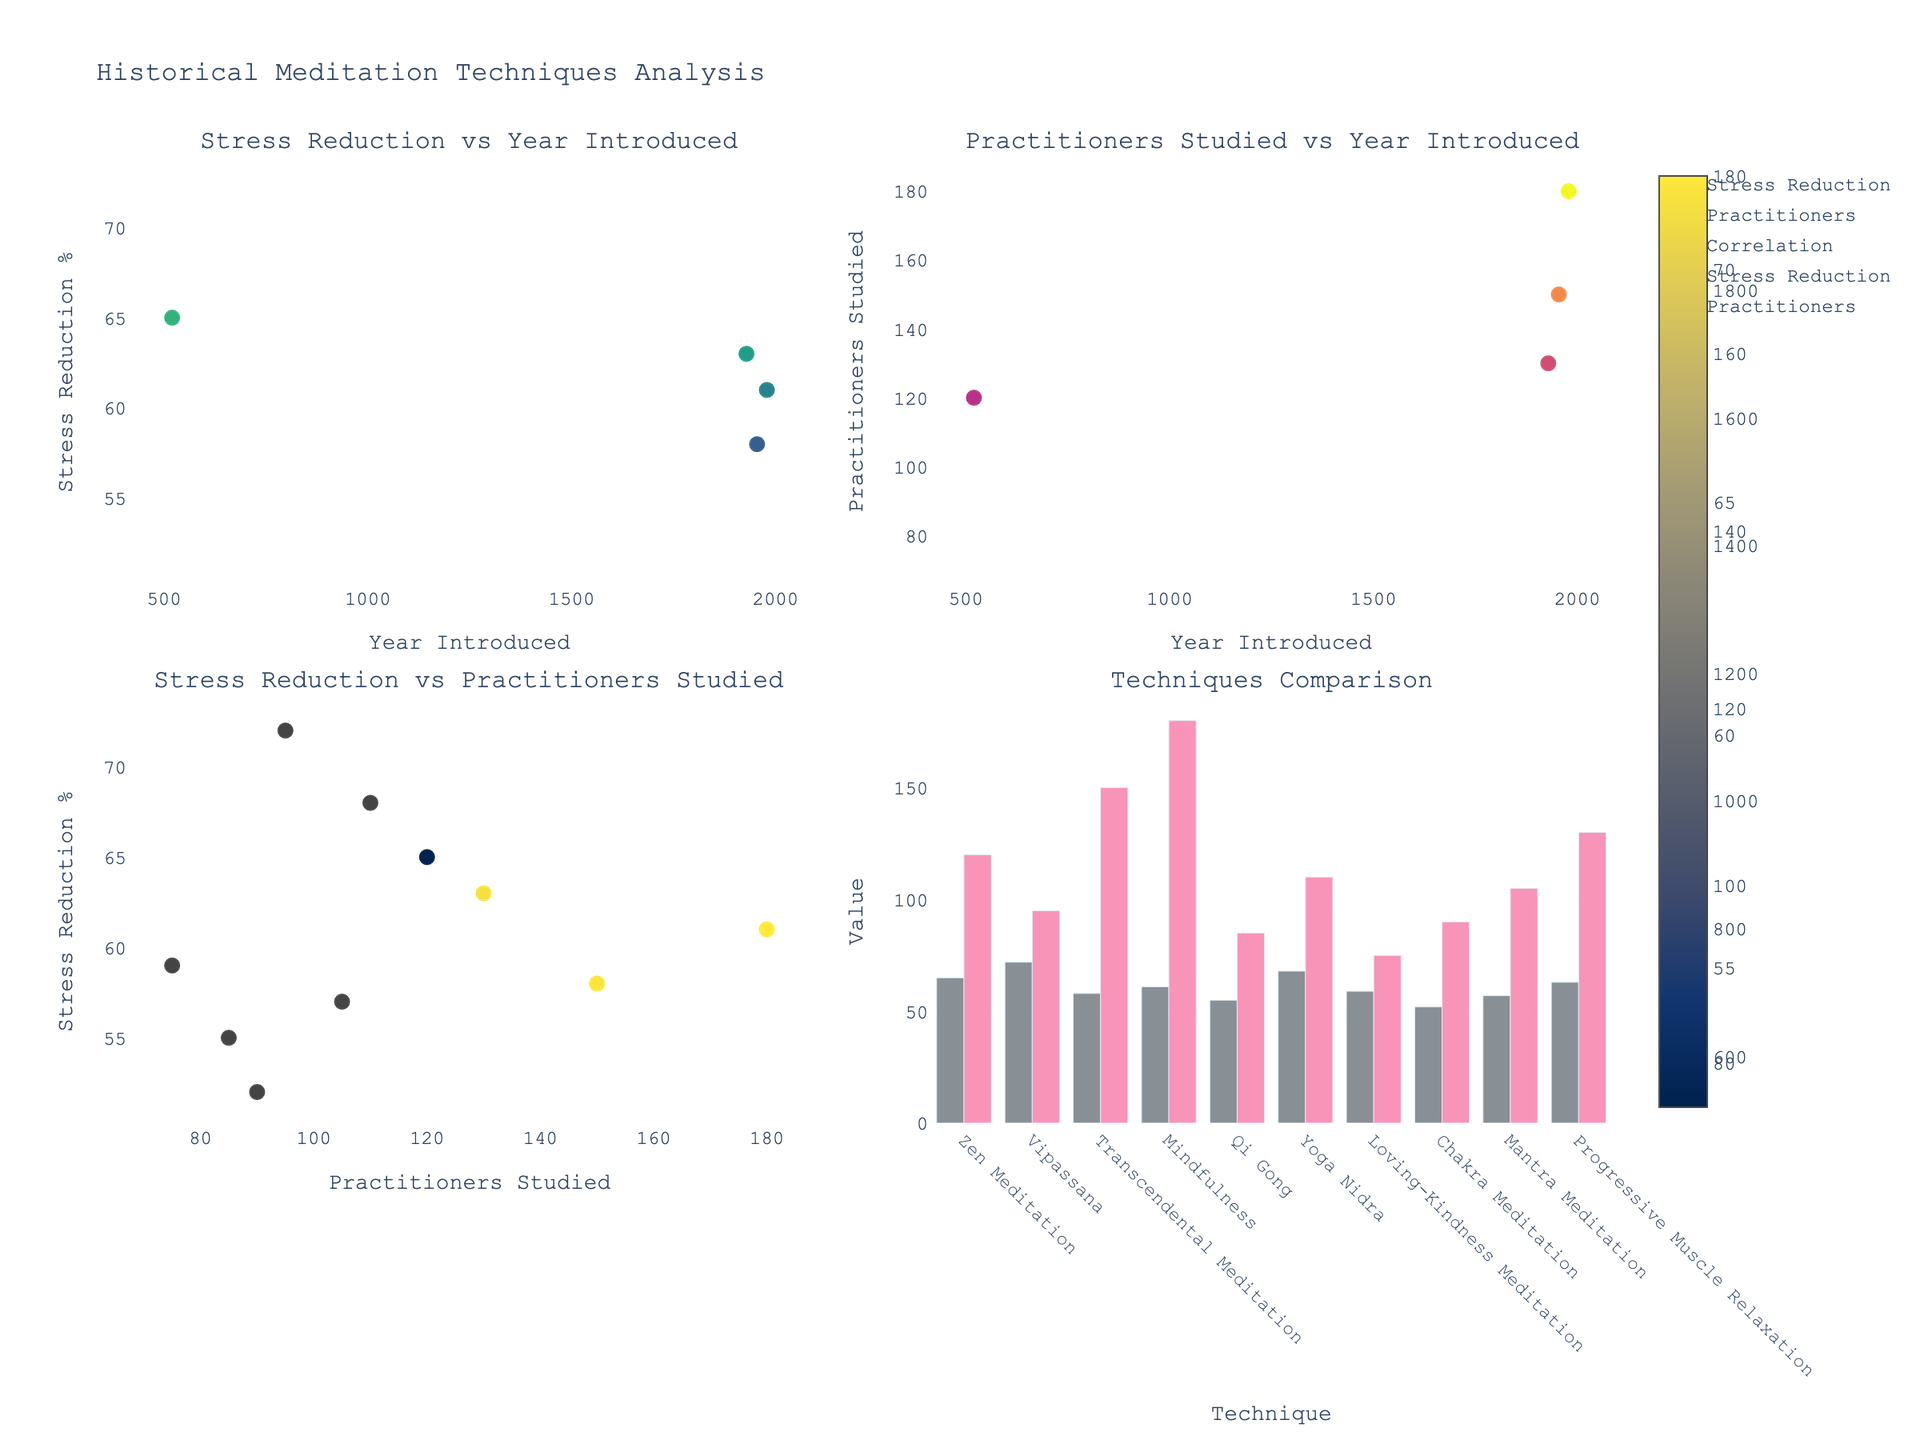What is the title of the figure? The title of the figure is located at the top center of the plot. It is meant to summarize what the figure is all about.
Answer: "Profit Margins for Organic Product Categories" Which category has the highest profit margin in Q4? Look at the bars in the Q4 column for all the categories. Identify the bar that reaches the highest value on the y-axis.
Answer: Organic Supplements What is the profit margin for Organic Dairy in Q3? Locate the subplot for Organic Dairy and refer to the height of the bar corresponding to Q3.
Answer: 17.1 How does the profit margin for Organic Beverages compare between Q1 and Q2? Look at the bars for Organic Beverages in Q1 and Q2 and compare their heights.
Answer: Q2 is higher What's the difference in profit margin for Organic Snacks between Q4 and Q1? Find the Q4 and Q1 bars for Organic Snacks and subtract the Q1 value from the Q4 value to get the difference.
Answer: 2.9 Which quarter had the lowest profit margin for Organic Produce? Look at all four bars under Organic Produce and identify the one with the smallest height.
Answer: Q1 Calculate the average profit margin for Organic Personal Care across all four quarters. Sum the profit margins for Organic Personal Care for all four quarters and then divide by the number of quarters (4).
Answer: 25.95 Which category shows a consistent increase in profit margin from Q1 to Q4? Look for a category where each subsequent quarter has a higher profit margin than the previous one. Identify the consistent upward trend.
Answer: Organic Supplements In which quarter does Organic Dairy have its highest profit margin? Look at the heights of the bars in all quarters for Organic Dairy and identify the highest one.
Answer: Q3 Compare the Q3 profit margins of Organic Produce and Organic Beverages. Which is higher? Locate the Q3 bars for both Organic Produce and Organic Beverages and compare their heights.
Answer: Organic Beverages 